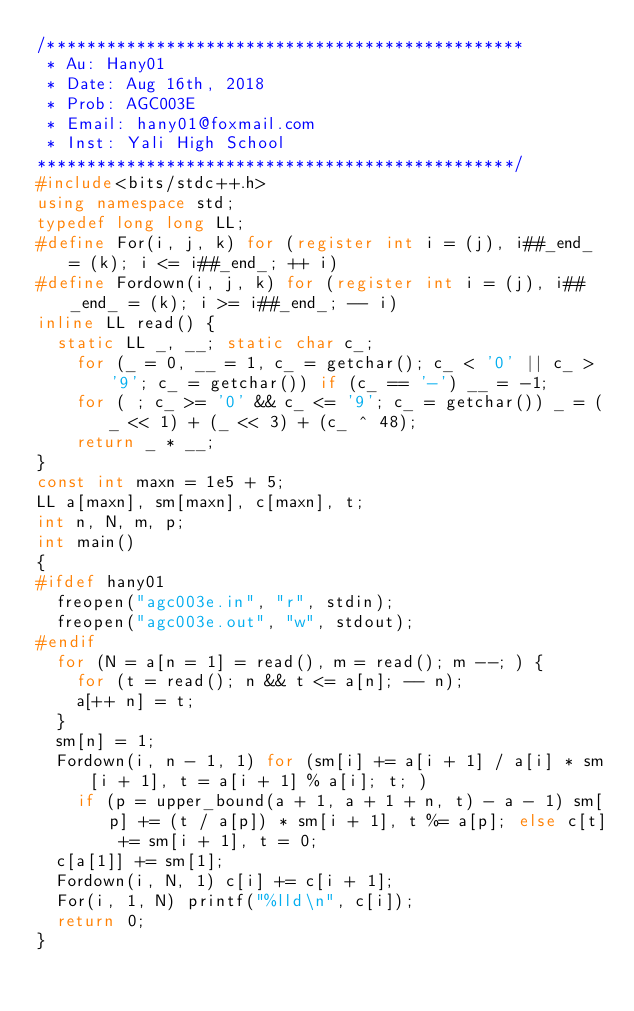Convert code to text. <code><loc_0><loc_0><loc_500><loc_500><_C++_>/************************************************
 * Au: Hany01
 * Date: Aug 16th, 2018
 * Prob: AGC003E
 * Email: hany01@foxmail.com
 * Inst: Yali High School
************************************************/
#include<bits/stdc++.h>
using namespace std;
typedef long long LL;
#define For(i, j, k) for (register int i = (j), i##_end_ = (k); i <= i##_end_; ++ i)
#define Fordown(i, j, k) for (register int i = (j), i##_end_ = (k); i >= i##_end_; -- i)
inline LL read() {
	static LL _, __; static char c_;
    for (_ = 0, __ = 1, c_ = getchar(); c_ < '0' || c_ > '9'; c_ = getchar()) if (c_ == '-') __ = -1;
    for ( ; c_ >= '0' && c_ <= '9'; c_ = getchar()) _ = (_ << 1) + (_ << 3) + (c_ ^ 48);
    return _ * __;
}
const int maxn = 1e5 + 5;
LL a[maxn], sm[maxn], c[maxn], t;
int n, N, m, p;
int main()
{
#ifdef hany01
	freopen("agc003e.in", "r", stdin);
	freopen("agc003e.out", "w", stdout);
#endif
	for (N = a[n = 1] = read(), m = read(); m --; ) {
		for (t = read(); n && t <= a[n]; -- n);
		a[++ n] = t;
	}
	sm[n] = 1;
	Fordown(i, n - 1, 1) for (sm[i] += a[i + 1] / a[i] * sm[i + 1], t = a[i + 1] % a[i]; t; )
		if (p = upper_bound(a + 1, a + 1 + n, t) - a - 1) sm[p] += (t / a[p]) * sm[i + 1], t %= a[p]; else c[t] += sm[i + 1], t = 0;
	c[a[1]] += sm[1];
	Fordown(i, N, 1) c[i] += c[i + 1];
	For(i, 1, N) printf("%lld\n", c[i]);
	return 0;
}</code> 